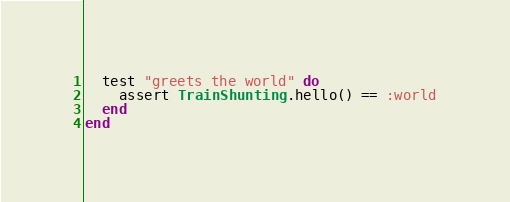<code> <loc_0><loc_0><loc_500><loc_500><_Elixir_>
  test "greets the world" do
    assert TrainShunting.hello() == :world
  end
end
</code> 